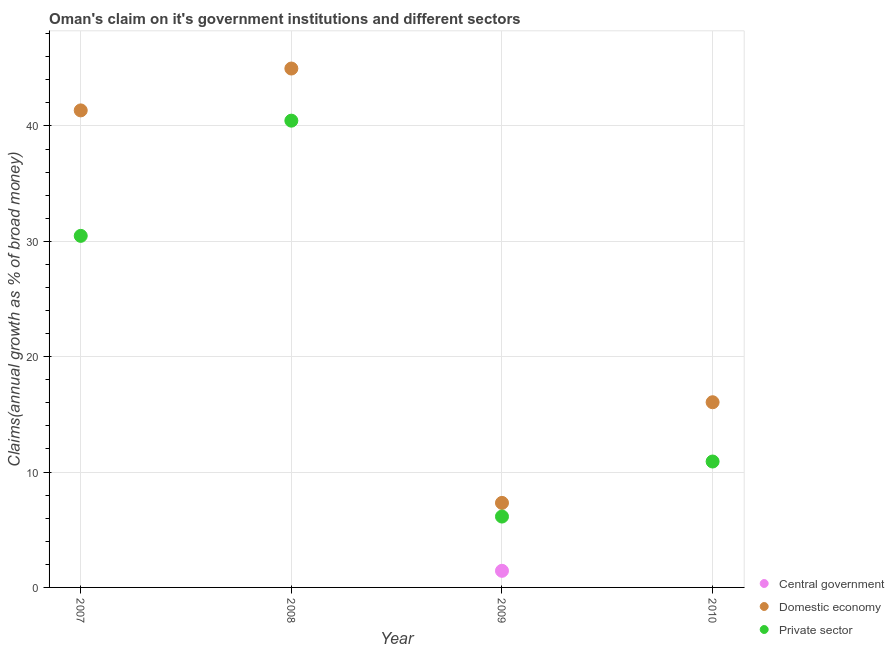How many different coloured dotlines are there?
Give a very brief answer. 3. What is the percentage of claim on the domestic economy in 2009?
Offer a terse response. 7.33. Across all years, what is the maximum percentage of claim on the central government?
Your answer should be compact. 1.44. Across all years, what is the minimum percentage of claim on the central government?
Your answer should be compact. 0. What is the total percentage of claim on the private sector in the graph?
Give a very brief answer. 87.99. What is the difference between the percentage of claim on the domestic economy in 2008 and that in 2009?
Make the answer very short. 37.65. What is the difference between the percentage of claim on the domestic economy in 2007 and the percentage of claim on the private sector in 2008?
Give a very brief answer. 0.89. What is the average percentage of claim on the domestic economy per year?
Ensure brevity in your answer.  27.43. In the year 2008, what is the difference between the percentage of claim on the private sector and percentage of claim on the domestic economy?
Provide a succinct answer. -4.52. What is the ratio of the percentage of claim on the domestic economy in 2007 to that in 2010?
Give a very brief answer. 2.58. Is the percentage of claim on the private sector in 2009 less than that in 2010?
Ensure brevity in your answer.  Yes. What is the difference between the highest and the second highest percentage of claim on the private sector?
Your answer should be very brief. 9.99. What is the difference between the highest and the lowest percentage of claim on the private sector?
Ensure brevity in your answer.  34.31. In how many years, is the percentage of claim on the central government greater than the average percentage of claim on the central government taken over all years?
Make the answer very short. 1. Does the percentage of claim on the central government monotonically increase over the years?
Offer a terse response. No. Is the percentage of claim on the private sector strictly less than the percentage of claim on the central government over the years?
Your answer should be very brief. No. How many dotlines are there?
Ensure brevity in your answer.  3. How many years are there in the graph?
Offer a terse response. 4. Are the values on the major ticks of Y-axis written in scientific E-notation?
Offer a terse response. No. Where does the legend appear in the graph?
Give a very brief answer. Bottom right. How are the legend labels stacked?
Your answer should be very brief. Vertical. What is the title of the graph?
Offer a very short reply. Oman's claim on it's government institutions and different sectors. Does "Gaseous fuel" appear as one of the legend labels in the graph?
Offer a terse response. No. What is the label or title of the Y-axis?
Offer a terse response. Claims(annual growth as % of broad money). What is the Claims(annual growth as % of broad money) in Central government in 2007?
Provide a short and direct response. 0. What is the Claims(annual growth as % of broad money) of Domestic economy in 2007?
Provide a succinct answer. 41.35. What is the Claims(annual growth as % of broad money) in Private sector in 2007?
Give a very brief answer. 30.47. What is the Claims(annual growth as % of broad money) in Domestic economy in 2008?
Make the answer very short. 44.98. What is the Claims(annual growth as % of broad money) in Private sector in 2008?
Your answer should be compact. 40.46. What is the Claims(annual growth as % of broad money) of Central government in 2009?
Make the answer very short. 1.44. What is the Claims(annual growth as % of broad money) in Domestic economy in 2009?
Your response must be concise. 7.33. What is the Claims(annual growth as % of broad money) in Private sector in 2009?
Make the answer very short. 6.14. What is the Claims(annual growth as % of broad money) in Domestic economy in 2010?
Give a very brief answer. 16.05. What is the Claims(annual growth as % of broad money) of Private sector in 2010?
Your answer should be very brief. 10.91. Across all years, what is the maximum Claims(annual growth as % of broad money) of Central government?
Keep it short and to the point. 1.44. Across all years, what is the maximum Claims(annual growth as % of broad money) of Domestic economy?
Your response must be concise. 44.98. Across all years, what is the maximum Claims(annual growth as % of broad money) in Private sector?
Your answer should be compact. 40.46. Across all years, what is the minimum Claims(annual growth as % of broad money) in Central government?
Offer a terse response. 0. Across all years, what is the minimum Claims(annual growth as % of broad money) in Domestic economy?
Keep it short and to the point. 7.33. Across all years, what is the minimum Claims(annual growth as % of broad money) of Private sector?
Your response must be concise. 6.14. What is the total Claims(annual growth as % of broad money) in Central government in the graph?
Your answer should be very brief. 1.44. What is the total Claims(annual growth as % of broad money) in Domestic economy in the graph?
Offer a very short reply. 109.7. What is the total Claims(annual growth as % of broad money) in Private sector in the graph?
Offer a very short reply. 87.99. What is the difference between the Claims(annual growth as % of broad money) in Domestic economy in 2007 and that in 2008?
Offer a very short reply. -3.63. What is the difference between the Claims(annual growth as % of broad money) in Private sector in 2007 and that in 2008?
Make the answer very short. -9.99. What is the difference between the Claims(annual growth as % of broad money) in Domestic economy in 2007 and that in 2009?
Provide a succinct answer. 34.02. What is the difference between the Claims(annual growth as % of broad money) of Private sector in 2007 and that in 2009?
Give a very brief answer. 24.33. What is the difference between the Claims(annual growth as % of broad money) in Domestic economy in 2007 and that in 2010?
Your answer should be very brief. 25.3. What is the difference between the Claims(annual growth as % of broad money) of Private sector in 2007 and that in 2010?
Offer a terse response. 19.56. What is the difference between the Claims(annual growth as % of broad money) of Domestic economy in 2008 and that in 2009?
Your answer should be compact. 37.65. What is the difference between the Claims(annual growth as % of broad money) of Private sector in 2008 and that in 2009?
Give a very brief answer. 34.31. What is the difference between the Claims(annual growth as % of broad money) of Domestic economy in 2008 and that in 2010?
Offer a very short reply. 28.92. What is the difference between the Claims(annual growth as % of broad money) in Private sector in 2008 and that in 2010?
Offer a terse response. 29.54. What is the difference between the Claims(annual growth as % of broad money) in Domestic economy in 2009 and that in 2010?
Provide a succinct answer. -8.72. What is the difference between the Claims(annual growth as % of broad money) in Private sector in 2009 and that in 2010?
Offer a very short reply. -4.77. What is the difference between the Claims(annual growth as % of broad money) of Domestic economy in 2007 and the Claims(annual growth as % of broad money) of Private sector in 2008?
Make the answer very short. 0.89. What is the difference between the Claims(annual growth as % of broad money) in Domestic economy in 2007 and the Claims(annual growth as % of broad money) in Private sector in 2009?
Provide a succinct answer. 35.2. What is the difference between the Claims(annual growth as % of broad money) in Domestic economy in 2007 and the Claims(annual growth as % of broad money) in Private sector in 2010?
Your response must be concise. 30.43. What is the difference between the Claims(annual growth as % of broad money) of Domestic economy in 2008 and the Claims(annual growth as % of broad money) of Private sector in 2009?
Provide a succinct answer. 38.83. What is the difference between the Claims(annual growth as % of broad money) of Domestic economy in 2008 and the Claims(annual growth as % of broad money) of Private sector in 2010?
Provide a succinct answer. 34.06. What is the difference between the Claims(annual growth as % of broad money) in Central government in 2009 and the Claims(annual growth as % of broad money) in Domestic economy in 2010?
Ensure brevity in your answer.  -14.61. What is the difference between the Claims(annual growth as % of broad money) of Central government in 2009 and the Claims(annual growth as % of broad money) of Private sector in 2010?
Keep it short and to the point. -9.47. What is the difference between the Claims(annual growth as % of broad money) in Domestic economy in 2009 and the Claims(annual growth as % of broad money) in Private sector in 2010?
Provide a short and direct response. -3.59. What is the average Claims(annual growth as % of broad money) in Central government per year?
Ensure brevity in your answer.  0.36. What is the average Claims(annual growth as % of broad money) of Domestic economy per year?
Make the answer very short. 27.43. What is the average Claims(annual growth as % of broad money) of Private sector per year?
Your answer should be compact. 22. In the year 2007, what is the difference between the Claims(annual growth as % of broad money) in Domestic economy and Claims(annual growth as % of broad money) in Private sector?
Keep it short and to the point. 10.88. In the year 2008, what is the difference between the Claims(annual growth as % of broad money) in Domestic economy and Claims(annual growth as % of broad money) in Private sector?
Provide a succinct answer. 4.52. In the year 2009, what is the difference between the Claims(annual growth as % of broad money) of Central government and Claims(annual growth as % of broad money) of Domestic economy?
Offer a very short reply. -5.89. In the year 2009, what is the difference between the Claims(annual growth as % of broad money) of Central government and Claims(annual growth as % of broad money) of Private sector?
Give a very brief answer. -4.7. In the year 2009, what is the difference between the Claims(annual growth as % of broad money) of Domestic economy and Claims(annual growth as % of broad money) of Private sector?
Keep it short and to the point. 1.18. In the year 2010, what is the difference between the Claims(annual growth as % of broad money) of Domestic economy and Claims(annual growth as % of broad money) of Private sector?
Offer a very short reply. 5.14. What is the ratio of the Claims(annual growth as % of broad money) of Domestic economy in 2007 to that in 2008?
Ensure brevity in your answer.  0.92. What is the ratio of the Claims(annual growth as % of broad money) of Private sector in 2007 to that in 2008?
Offer a terse response. 0.75. What is the ratio of the Claims(annual growth as % of broad money) in Domestic economy in 2007 to that in 2009?
Ensure brevity in your answer.  5.64. What is the ratio of the Claims(annual growth as % of broad money) of Private sector in 2007 to that in 2009?
Provide a short and direct response. 4.96. What is the ratio of the Claims(annual growth as % of broad money) of Domestic economy in 2007 to that in 2010?
Give a very brief answer. 2.58. What is the ratio of the Claims(annual growth as % of broad money) in Private sector in 2007 to that in 2010?
Give a very brief answer. 2.79. What is the ratio of the Claims(annual growth as % of broad money) in Domestic economy in 2008 to that in 2009?
Keep it short and to the point. 6.14. What is the ratio of the Claims(annual growth as % of broad money) in Private sector in 2008 to that in 2009?
Keep it short and to the point. 6.59. What is the ratio of the Claims(annual growth as % of broad money) of Domestic economy in 2008 to that in 2010?
Your response must be concise. 2.8. What is the ratio of the Claims(annual growth as % of broad money) in Private sector in 2008 to that in 2010?
Offer a very short reply. 3.71. What is the ratio of the Claims(annual growth as % of broad money) of Domestic economy in 2009 to that in 2010?
Your response must be concise. 0.46. What is the ratio of the Claims(annual growth as % of broad money) of Private sector in 2009 to that in 2010?
Offer a very short reply. 0.56. What is the difference between the highest and the second highest Claims(annual growth as % of broad money) in Domestic economy?
Offer a very short reply. 3.63. What is the difference between the highest and the second highest Claims(annual growth as % of broad money) of Private sector?
Ensure brevity in your answer.  9.99. What is the difference between the highest and the lowest Claims(annual growth as % of broad money) in Central government?
Keep it short and to the point. 1.44. What is the difference between the highest and the lowest Claims(annual growth as % of broad money) in Domestic economy?
Ensure brevity in your answer.  37.65. What is the difference between the highest and the lowest Claims(annual growth as % of broad money) of Private sector?
Provide a short and direct response. 34.31. 